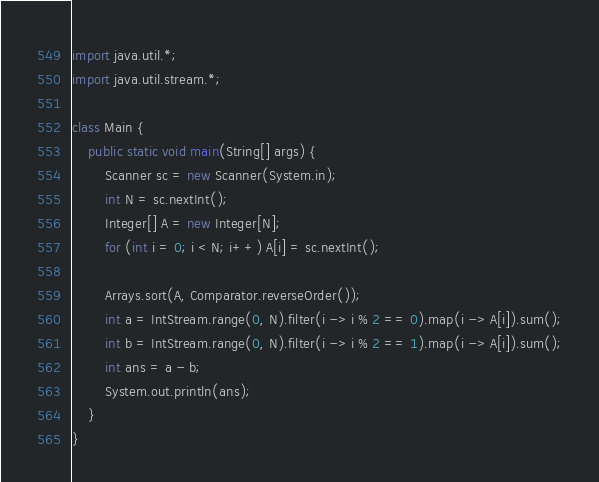Convert code to text. <code><loc_0><loc_0><loc_500><loc_500><_Java_>import java.util.*;
import java.util.stream.*;

class Main {
    public static void main(String[] args) {
        Scanner sc = new Scanner(System.in);
        int N = sc.nextInt();
        Integer[] A = new Integer[N];
        for (int i = 0; i < N; i++) A[i] = sc.nextInt();

        Arrays.sort(A, Comparator.reverseOrder());
        int a = IntStream.range(0, N).filter(i -> i % 2 == 0).map(i -> A[i]).sum();
        int b = IntStream.range(0, N).filter(i -> i % 2 == 1).map(i -> A[i]).sum();
        int ans = a - b;
        System.out.println(ans);
    }
}</code> 